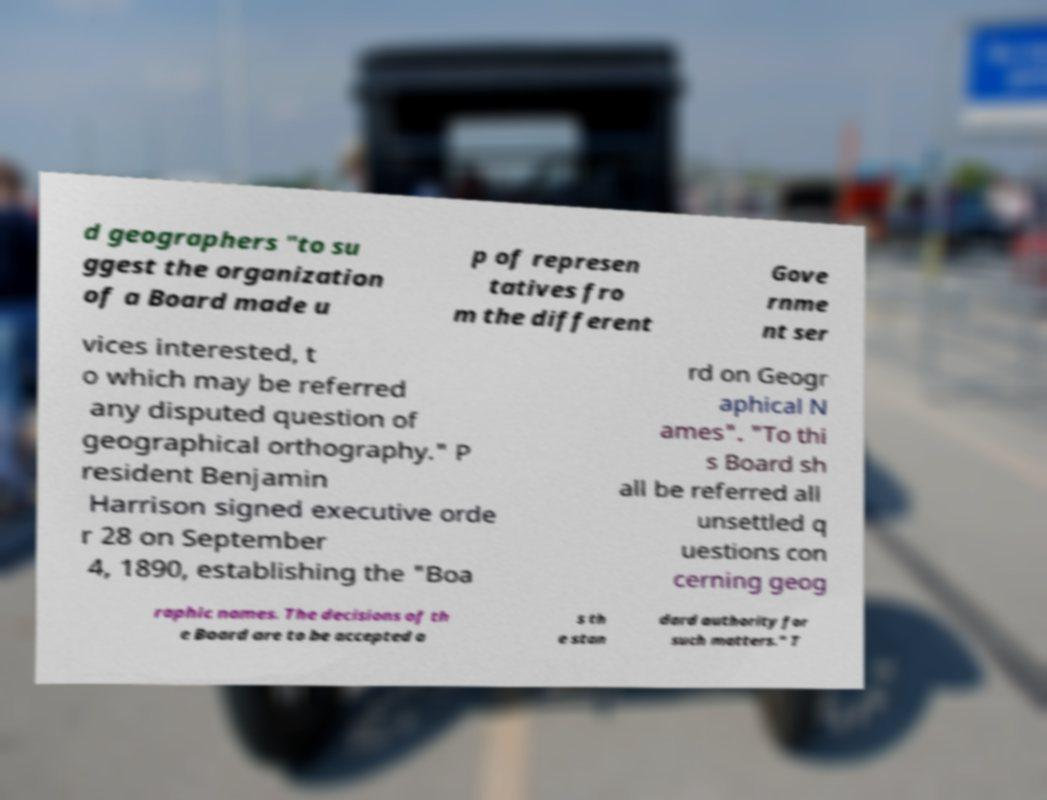Can you accurately transcribe the text from the provided image for me? d geographers "to su ggest the organization of a Board made u p of represen tatives fro m the different Gove rnme nt ser vices interested, t o which may be referred any disputed question of geographical orthography." P resident Benjamin Harrison signed executive orde r 28 on September 4, 1890, establishing the "Boa rd on Geogr aphical N ames". "To thi s Board sh all be referred all unsettled q uestions con cerning geog raphic names. The decisions of th e Board are to be accepted a s th e stan dard authority for such matters." T 